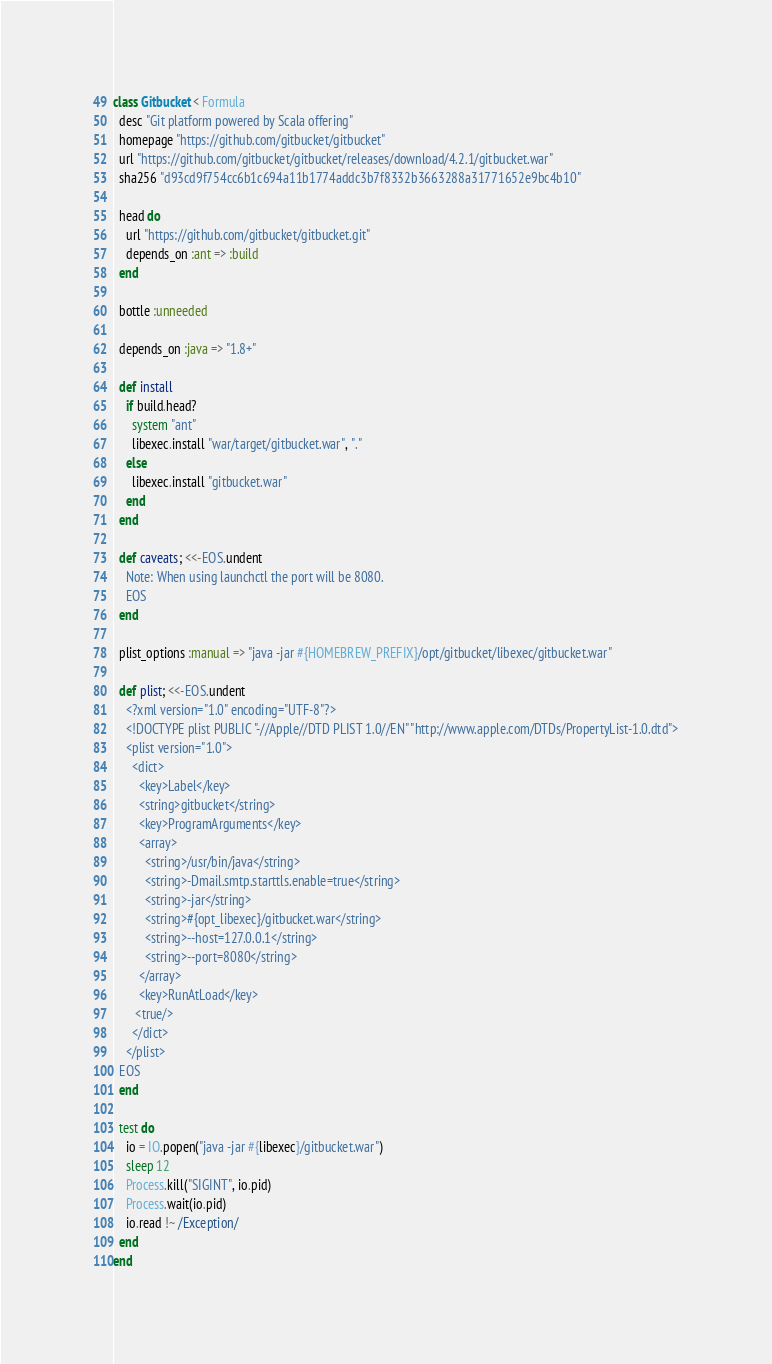Convert code to text. <code><loc_0><loc_0><loc_500><loc_500><_Ruby_>class Gitbucket < Formula
  desc "Git platform powered by Scala offering"
  homepage "https://github.com/gitbucket/gitbucket"
  url "https://github.com/gitbucket/gitbucket/releases/download/4.2.1/gitbucket.war"
  sha256 "d93cd9f754cc6b1c694a11b1774addc3b7f8332b3663288a31771652e9bc4b10"

  head do
    url "https://github.com/gitbucket/gitbucket.git"
    depends_on :ant => :build
  end

  bottle :unneeded

  depends_on :java => "1.8+"

  def install
    if build.head?
      system "ant"
      libexec.install "war/target/gitbucket.war", "."
    else
      libexec.install "gitbucket.war"
    end
  end

  def caveats; <<-EOS.undent
    Note: When using launchctl the port will be 8080.
    EOS
  end

  plist_options :manual => "java -jar #{HOMEBREW_PREFIX}/opt/gitbucket/libexec/gitbucket.war"

  def plist; <<-EOS.undent
    <?xml version="1.0" encoding="UTF-8"?>
    <!DOCTYPE plist PUBLIC "-//Apple//DTD PLIST 1.0//EN" "http://www.apple.com/DTDs/PropertyList-1.0.dtd">
    <plist version="1.0">
      <dict>
        <key>Label</key>
        <string>gitbucket</string>
        <key>ProgramArguments</key>
        <array>
          <string>/usr/bin/java</string>
          <string>-Dmail.smtp.starttls.enable=true</string>
          <string>-jar</string>
          <string>#{opt_libexec}/gitbucket.war</string>
          <string>--host=127.0.0.1</string>
          <string>--port=8080</string>
        </array>
        <key>RunAtLoad</key>
       <true/>
      </dict>
    </plist>
  EOS
  end

  test do
    io = IO.popen("java -jar #{libexec}/gitbucket.war")
    sleep 12
    Process.kill("SIGINT", io.pid)
    Process.wait(io.pid)
    io.read !~ /Exception/
  end
end
</code> 